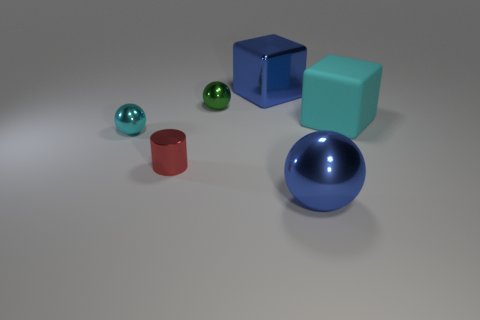Do the blue shiny object that is in front of the red metal object and the tiny cyan shiny thing have the same shape?
Ensure brevity in your answer.  Yes. There is a blue sphere that is the same size as the cyan matte thing; what material is it?
Offer a very short reply. Metal. Is the number of big blocks in front of the green shiny object the same as the number of metallic blocks that are behind the tiny cyan metallic object?
Offer a terse response. Yes. There is a blue thing behind the large blue metallic thing that is in front of the cyan metal ball; what number of large blue metallic things are right of it?
Provide a short and direct response. 1. Does the large rubber cube have the same color as the small sphere in front of the large cyan rubber cube?
Your response must be concise. Yes. What is the size of the green sphere that is the same material as the cylinder?
Ensure brevity in your answer.  Small. Are there more blue things in front of the small cyan metallic sphere than small cyan spheres?
Give a very brief answer. No. What material is the large object that is to the left of the large metal thing in front of the blue metal thing on the left side of the large blue ball?
Give a very brief answer. Metal. Is the material of the tiny red thing the same as the cyan thing left of the large cyan rubber object?
Provide a short and direct response. Yes. There is a big blue thing that is the same shape as the green thing; what material is it?
Make the answer very short. Metal. 